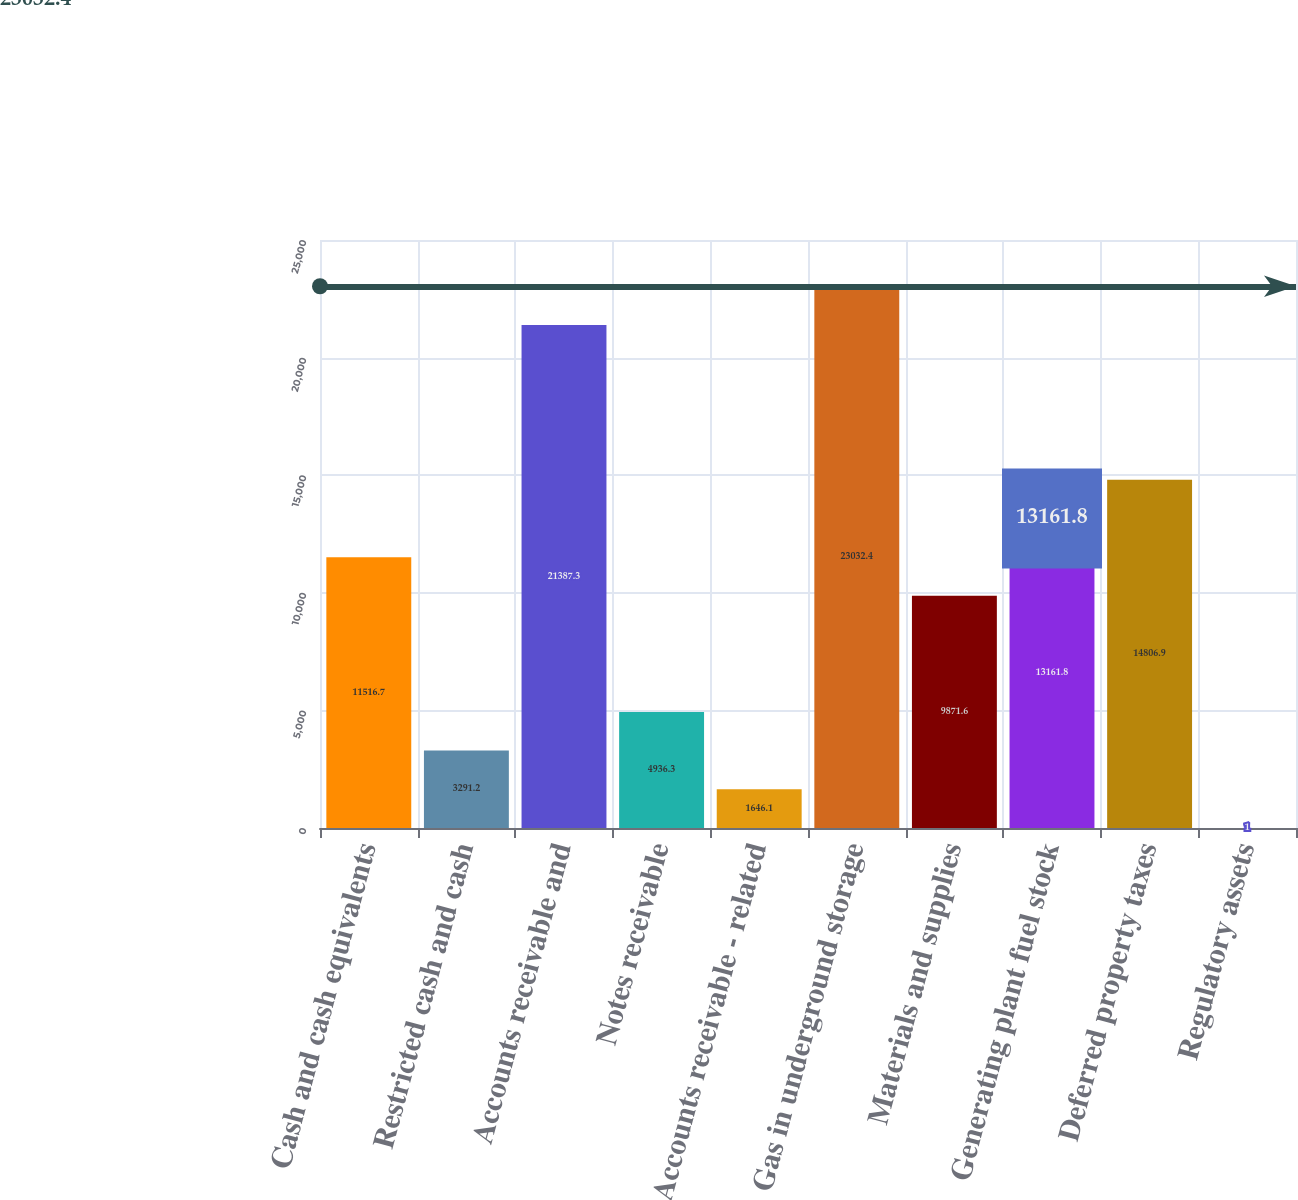Convert chart to OTSL. <chart><loc_0><loc_0><loc_500><loc_500><bar_chart><fcel>Cash and cash equivalents<fcel>Restricted cash and cash<fcel>Accounts receivable and<fcel>Notes receivable<fcel>Accounts receivable - related<fcel>Gas in underground storage<fcel>Materials and supplies<fcel>Generating plant fuel stock<fcel>Deferred property taxes<fcel>Regulatory assets<nl><fcel>11516.7<fcel>3291.2<fcel>21387.3<fcel>4936.3<fcel>1646.1<fcel>23032.4<fcel>9871.6<fcel>13161.8<fcel>14806.9<fcel>1<nl></chart> 